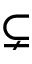<formula> <loc_0><loc_0><loc_500><loc_500>\subsetneq</formula> 